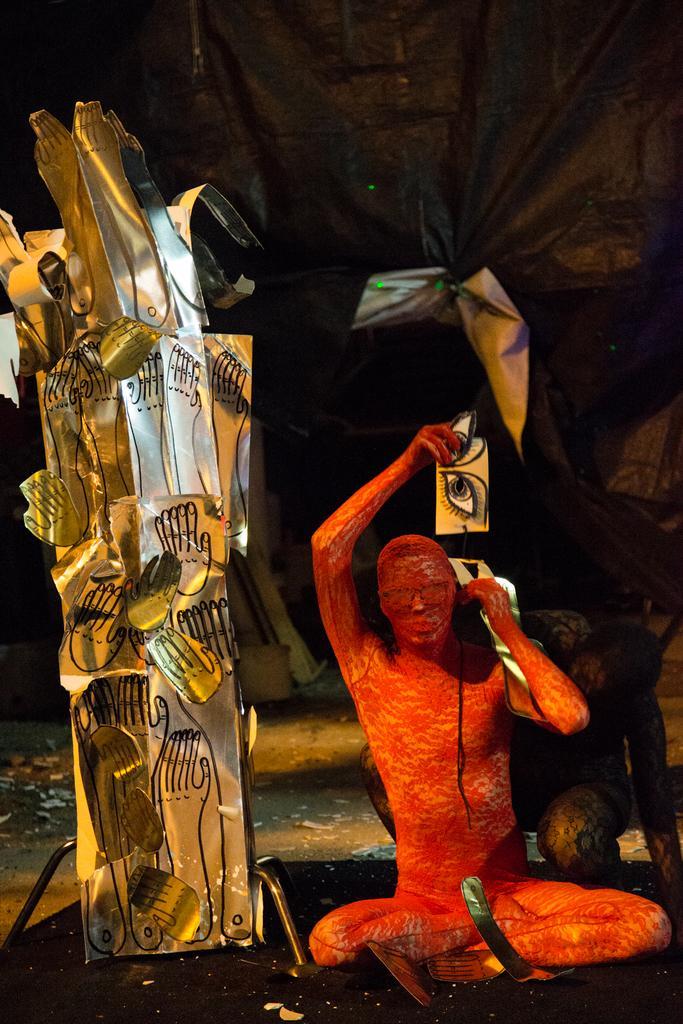Please provide a concise description of this image. In this image we can see the visual art of a person holding the eye pictures in the hands. This is looking like a stainless steel object with hand paintings on it and it is on the left side. 